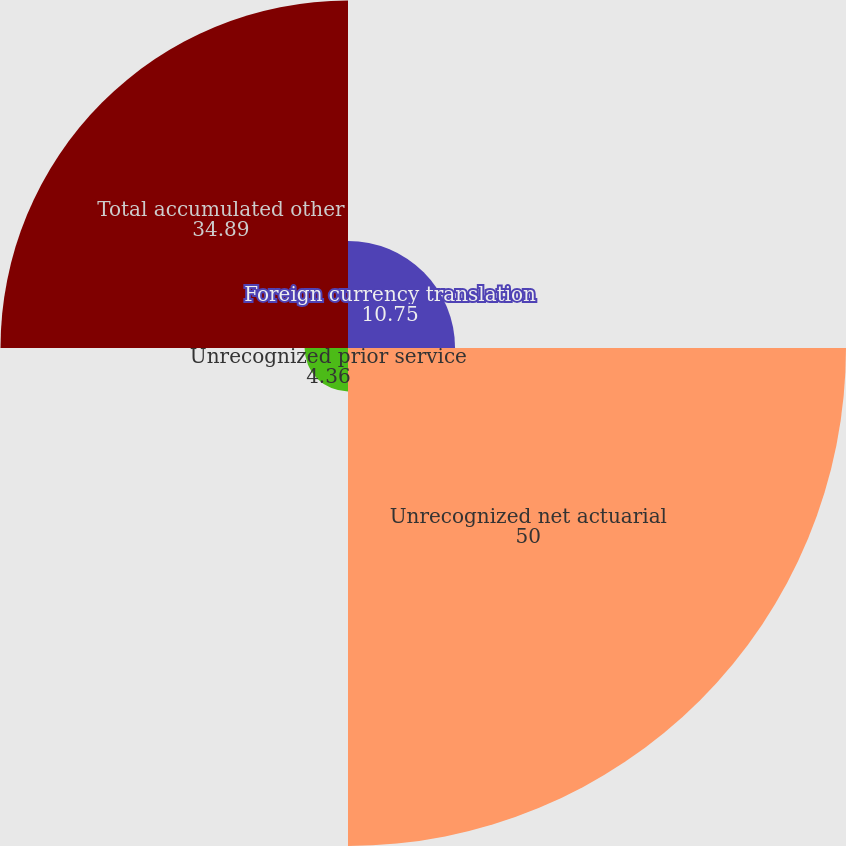<chart> <loc_0><loc_0><loc_500><loc_500><pie_chart><fcel>Foreign currency translation<fcel>Unrecognized net actuarial<fcel>Unrecognized prior service<fcel>Total accumulated other<nl><fcel>10.75%<fcel>50.0%<fcel>4.36%<fcel>34.89%<nl></chart> 